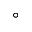Convert formula to latex. <formula><loc_0><loc_0><loc_500><loc_500>\circ</formula> 